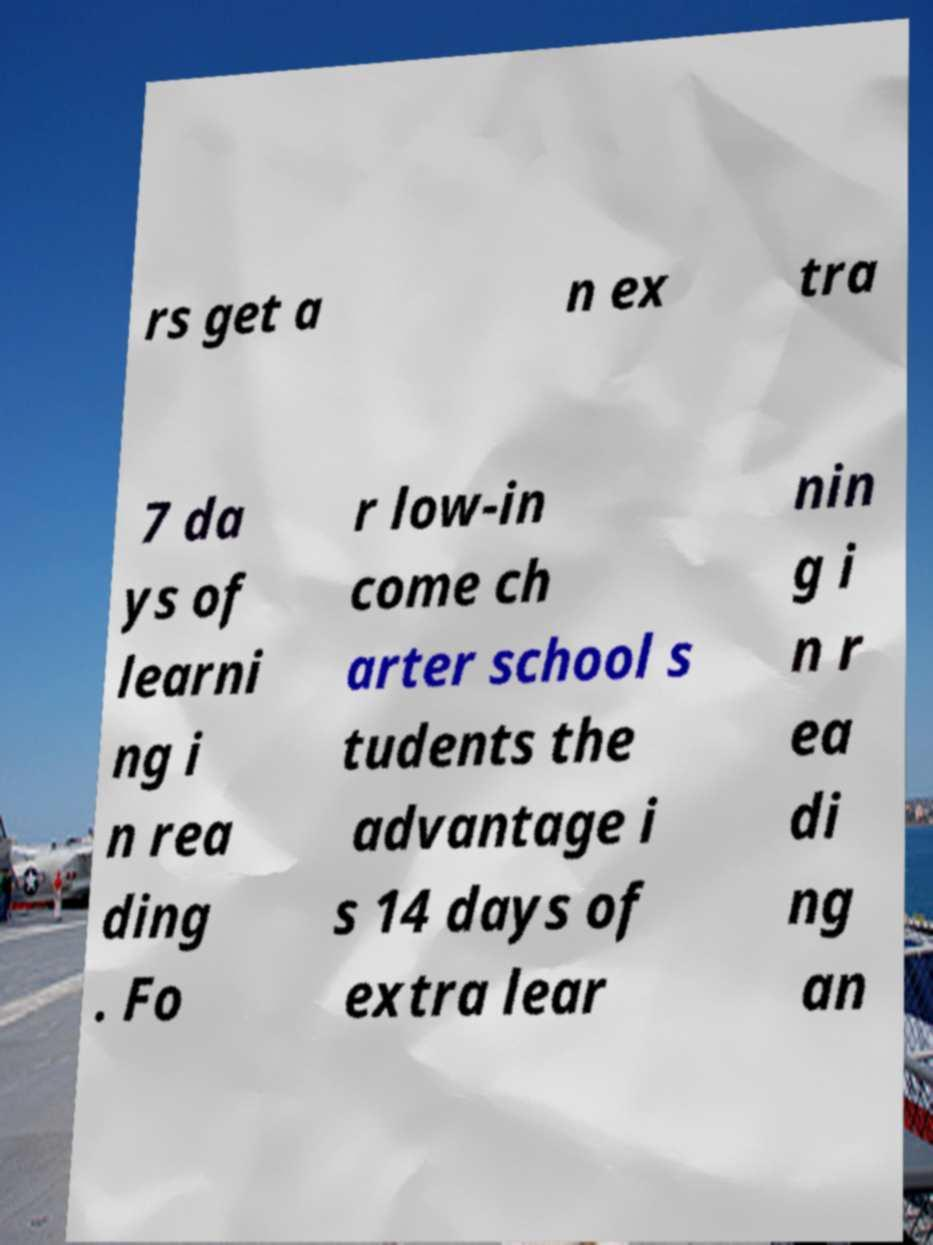Can you accurately transcribe the text from the provided image for me? rs get a n ex tra 7 da ys of learni ng i n rea ding . Fo r low-in come ch arter school s tudents the advantage i s 14 days of extra lear nin g i n r ea di ng an 